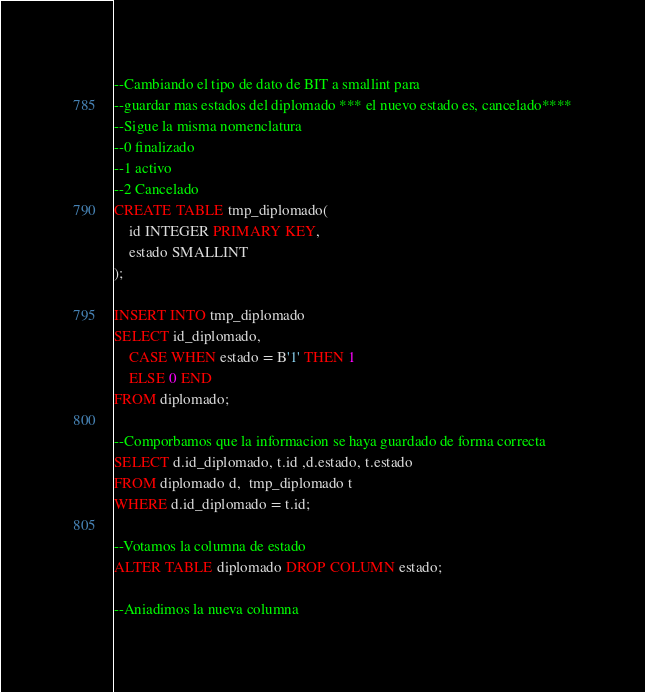<code> <loc_0><loc_0><loc_500><loc_500><_SQL_>--Cambiando el tipo de dato de BIT a smallint para
--guardar mas estados del diplomado *** el nuevo estado es, cancelado****
--Sigue la misma nomenclatura 
--0 finalizado
--1 activo
--2 Cancelado
CREATE TABLE tmp_diplomado(
	id INTEGER PRIMARY KEY,
	estado SMALLINT
);

INSERT INTO tmp_diplomado
SELECT id_diplomado, 
	CASE WHEN estado = B'1' THEN 1
	ELSE 0 END
FROM diplomado;

--Comporbamos que la informacion se haya guardado de forma correcta
SELECT d.id_diplomado, t.id ,d.estado, t.estado
FROM diplomado d,  tmp_diplomado t
WHERE d.id_diplomado = t.id;

--Votamos la columna de estado
ALTER TABLE diplomado DROP COLUMN estado;

--Aniadimos la nueva columna</code> 